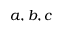<formula> <loc_0><loc_0><loc_500><loc_500>a , b , c</formula> 